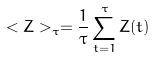Convert formula to latex. <formula><loc_0><loc_0><loc_500><loc_500>< Z > _ { \tau } = \frac { 1 } { \tau } \sum _ { t = 1 } ^ { \tau } Z ( t )</formula> 